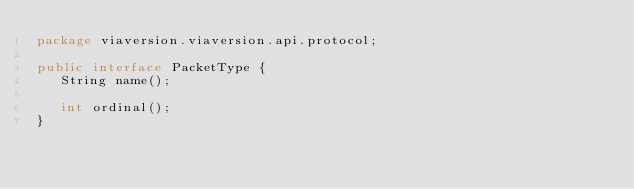<code> <loc_0><loc_0><loc_500><loc_500><_Java_>package viaversion.viaversion.api.protocol;

public interface PacketType {
   String name();

   int ordinal();
}
</code> 